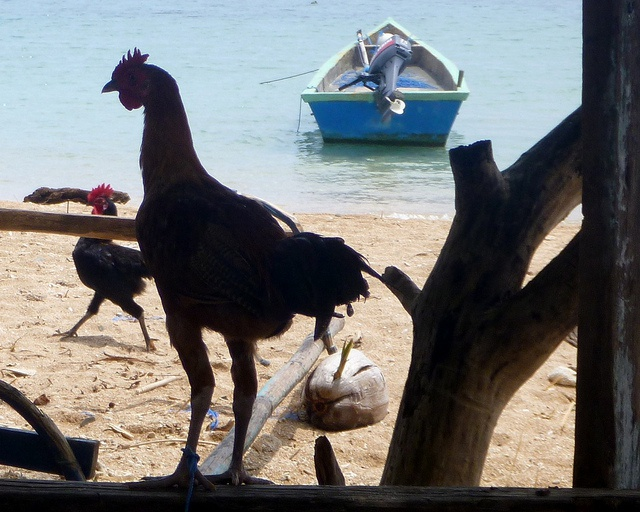Describe the objects in this image and their specific colors. I can see bird in lightblue, black, navy, gray, and lightgray tones, boat in lightblue, blue, and gray tones, and bird in lightblue, black, maroon, and gray tones in this image. 